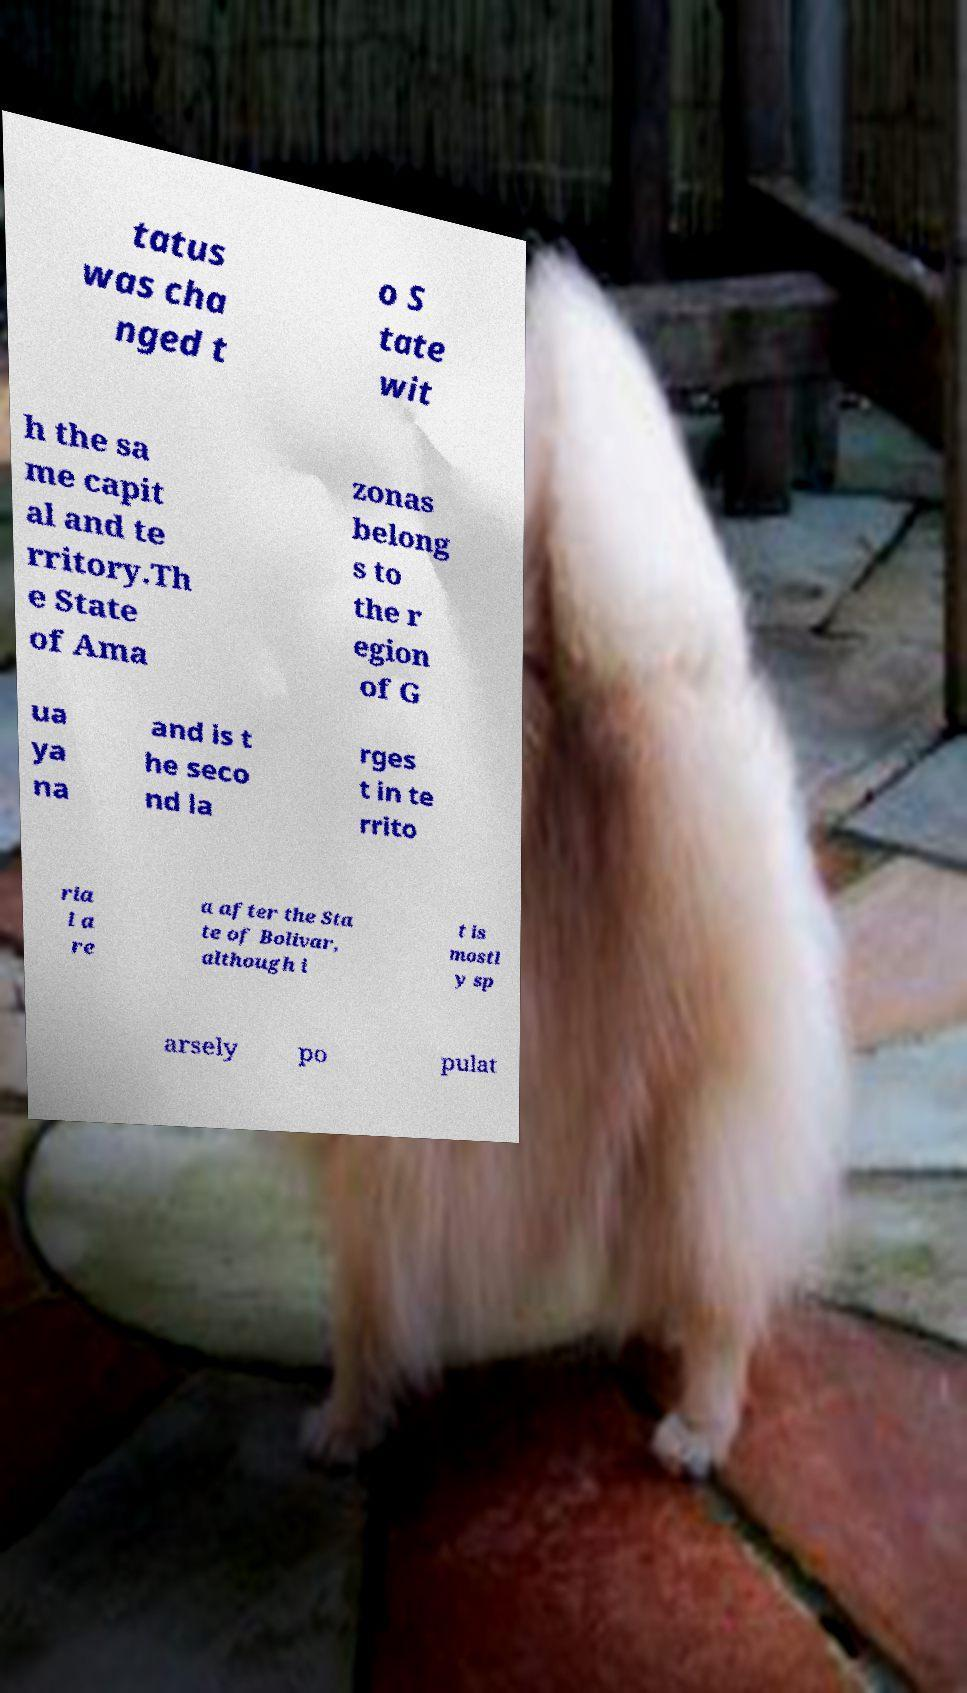Could you assist in decoding the text presented in this image and type it out clearly? tatus was cha nged t o S tate wit h the sa me capit al and te rritory.Th e State of Ama zonas belong s to the r egion of G ua ya na and is t he seco nd la rges t in te rrito ria l a re a after the Sta te of Bolivar, although i t is mostl y sp arsely po pulat 